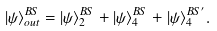<formula> <loc_0><loc_0><loc_500><loc_500>| \psi \rangle _ { o u t } ^ { B S } = | \psi \rangle _ { 2 } ^ { B S } + | \psi \rangle _ { 4 } ^ { B S } + | \psi \rangle _ { 4 } ^ { B S ^ { \prime } } .</formula> 